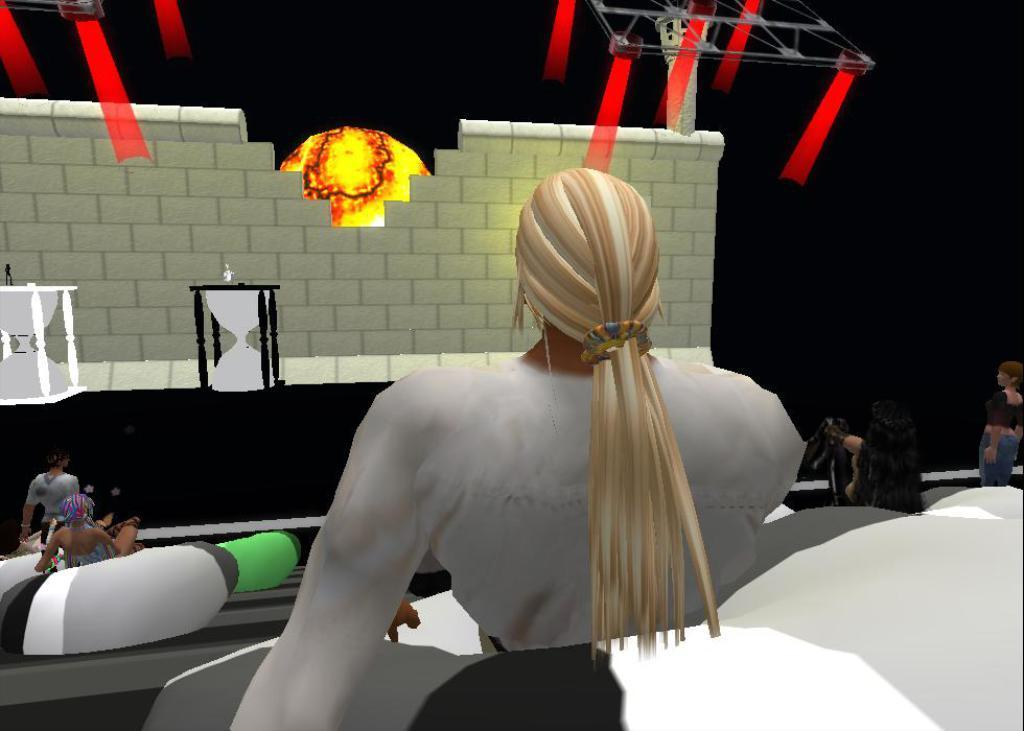What type of image is being described? The image is an animation. What can be seen in the animation? There are people in the image. What can be seen in the background of the animation? There appears to be a wall in the background of the image. What can be seen illuminating the scene? There are lights visible in the image. How would you describe the overall lighting in the image? The background of the image is dark. What shape does the voice take in the image? There is no voice present in the image, as it is an animation with visual elements only. 